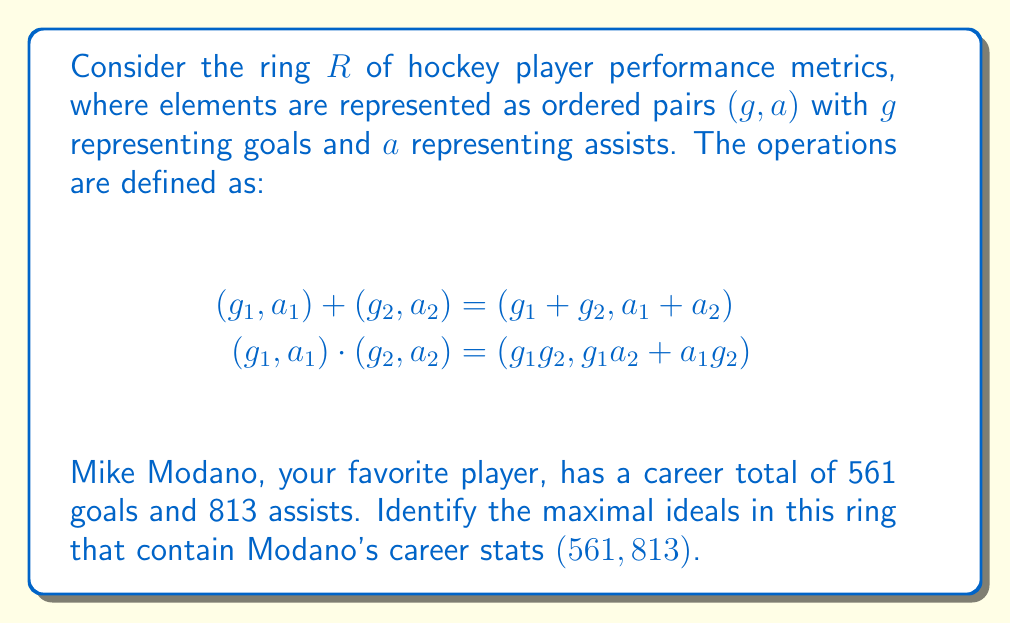What is the answer to this math problem? Let's approach this step-by-step:

1) First, recall that in a commutative ring with unity, maximal ideals are precisely the kernels of homomorphisms onto fields.

2) In our ring $R$, the only possible field homomorphic images are $\mathbb{Z}_p$ where $p$ is prime. This is because our ring is a subring of $\mathbb{Z} \times \mathbb{Z}$.

3) For a homomorphism $\phi: R \rightarrow \mathbb{Z}_p$, we must have:

   $$\phi(g, a) = (g + a) \mod p$$

   This is because $\phi(1, 0) + \phi(0, 1) = \phi(1, 1) = 1$ in $\mathbb{Z}_p$.

4) Now, for Modano's stats to be in the kernel of $\phi$, we need:

   $$\phi(561, 813) = (561 + 813) \mod p = 1374 \mod p = 0$$

5) This means $p$ must divide 1374. The prime factors of 1374 are 2, 3, and 229.

6) Therefore, there are three maximal ideals containing Modano's stats:

   $M_2 = \{(g, a) \in R : g + a \text{ is even}\}$
   $M_3 = \{(g, a) \in R : g + a \text{ is divisible by 3}\}$
   $M_{229} = \{(g, a) \in R : g + a \text{ is divisible by 229}\}$

These are indeed maximal because $R/M_2 \cong \mathbb{Z}_2$, $R/M_3 \cong \mathbb{Z}_3$, and $R/M_{229} \cong \mathbb{Z}_{229}$, which are all fields.
Answer: $M_2, M_3, M_{229}$ 